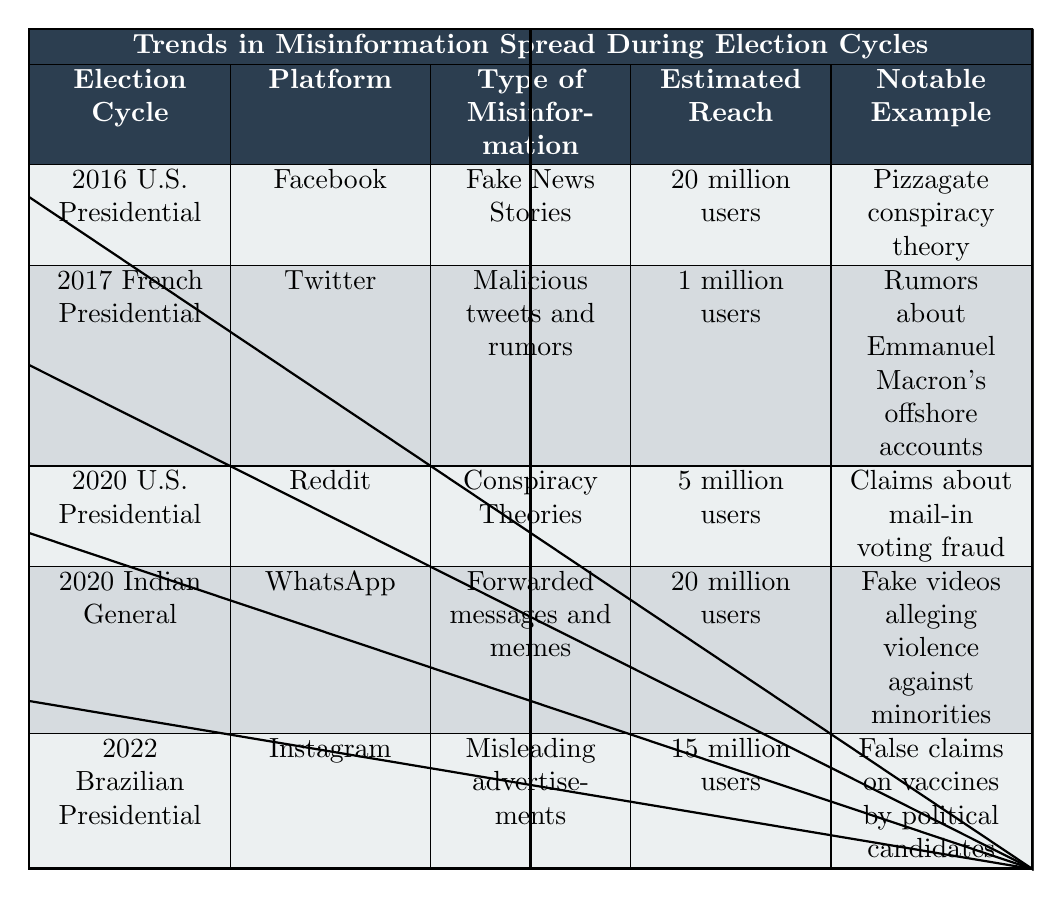What is the type of misinformation associated with the 2022 Brazilian Presidential Election? Referring to the table, the 2022 Brazilian Presidential Election is associated with the type of misinformation labeled as "Misleading advertisements."
Answer: Misleading advertisements Which platform had the highest estimated reach for misinformation during the listed election cycles? Comparing the estimated reach values, the highest is "20 million users," which appears for both the 2016 U.S. Presidential Election on Facebook and the 2020 Indian General Election on WhatsApp, but since they are equal, both are the highest.
Answer: Facebook and WhatsApp Was the misinformation during the 2017 French Presidential Election spread through social media? The source of misinformation in the 2017 French Presidential Election was attributed to "Spam Bots" on Twitter, which is a form of social media.
Answer: Yes Calculate the total estimated reach for misinformation across all election cycles listed in the table. Summing the estimated reach, we have 20 million (2016) + 1 million (2017) + 5 million (2020 U.S.) + 20 million (2020 India) + 15 million (2022) = 61 million users total.
Answer: 61 million users What notable example of misinformation spread during the 2020 U.S. Presidential Election? The table lists the notable example for the 2020 U.S. Presidential Election as "Claims about mail-in voting fraud."
Answer: Claims about mail-in voting fraud During which election cycle did misinformation lead to mob harassment? The table indicates that mob harassment occurred during the 2016 U.S. Presidential Election as a result of the Pizzagate conspiracy theory.
Answer: 2016 U.S. Presidential Election Identify the type of misinformation that reached 1 million users in the 2017 French Presidential Election. According to the table, the type of misinformation that reached 1 million users in the 2017 French Presidential Election is "Malicious tweets and rumors."
Answer: Malicious tweets and rumors Considering the platforms used for misinformation, which one was used in both the 2020 U.S. Presidential Election and the 2020 Indian General Election? The platforms used were Reddit for the 2020 U.S. Presidential Election and WhatsApp for the 2020 Indian General Election. Therefore, there is no common platform between these two election cycles.
Answer: None How many fact-checking organizations were involved with the misinformation during the 2022 Brazilian Presidential Election? The table lists two organizations involved with the misinformation for the 2022 Brazilian Presidential Election: "Estado de Minas" and "Aos Fatos."
Answer: 2 organizations Which election cycles involved misinformation that reached more than 15 million users? Analyzing the estimated reach, the 2016 U.S. Presidential Election (20 million) and 2020 Indian General Election (20 million) both had estimated reaches greater than 15 million users.
Answer: 2016 U.S. and 2020 Indian General Elections 